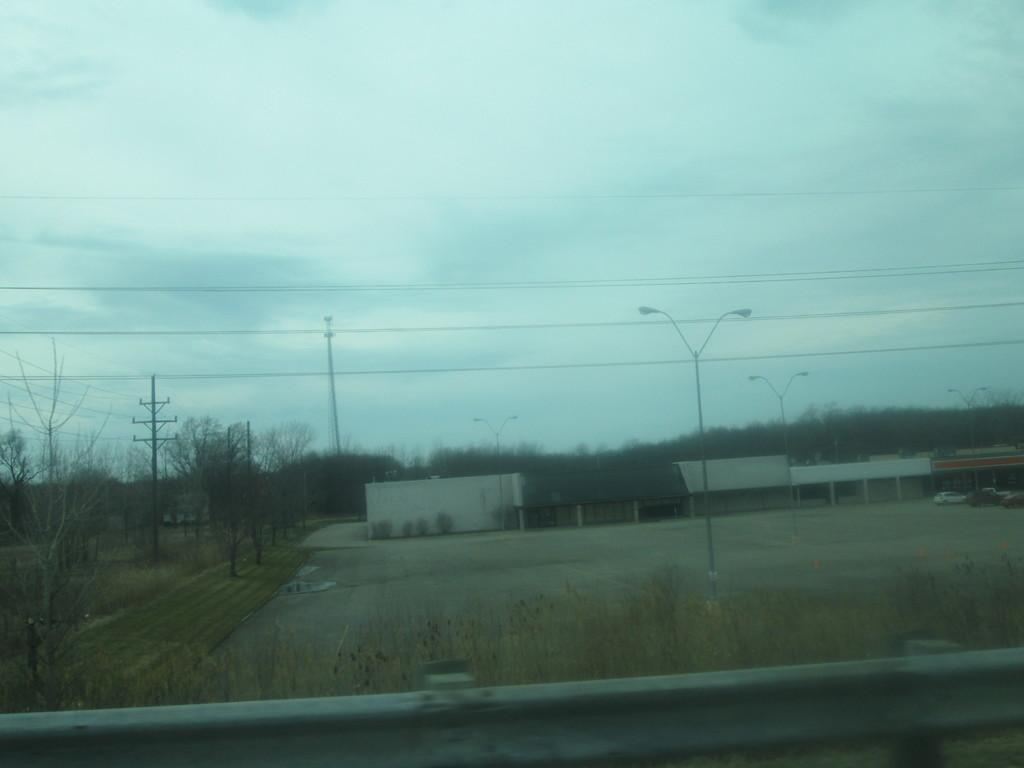What type of structures can be seen in the image? There are light poles, houses, and fencing at the bottom of the image. What else can be seen in the image besides structures? There are wires, vehicles, grass, trees, and the sky is visible in the image. What type of pollution can be seen in the image? There is no pollution visible in the image. What type of regret is expressed by the trees in the image? There is no regret expressed by the trees or any other elements in the image. 